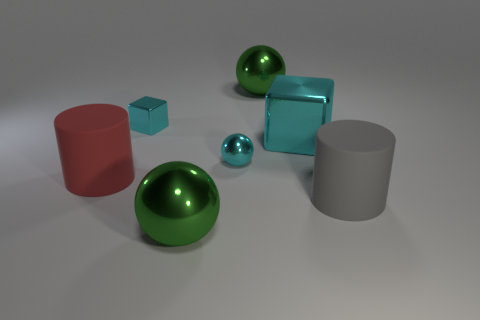If this were a physical composition, what materials do you think the objects are made of? Judging by the visual characteristics, the spheres, due to their reflective surfaces, could be made of a polished metal or glass. The cylinders and blocks, which lack reflection and appear to have a matte finish, might be constructed from a solid material like plastic or painted wood. The subtle differences in texture and the way they interact with light suggest they are meant to represent a variety of materials. 